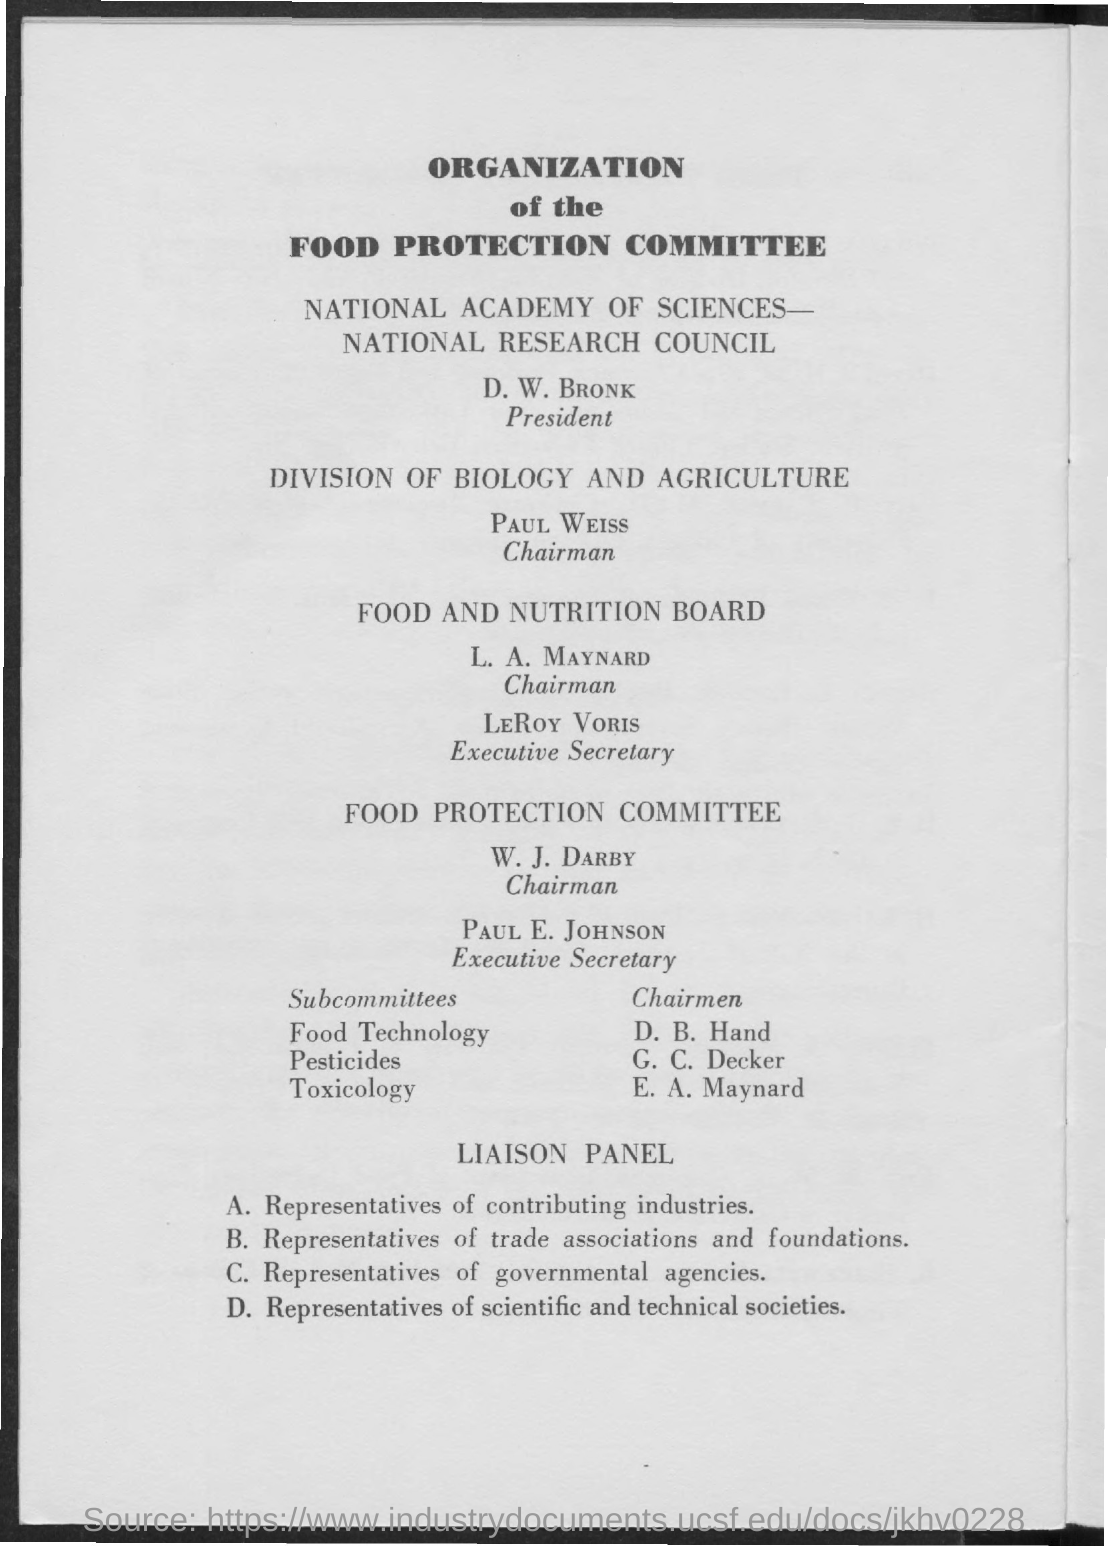Indicate a few pertinent items in this graphic. The Chairman of the Food and Nutrition Board is L. A. Maynard. The Food Protection Committee has an Executive Secretary named Paul E. Johnson. The executive secretary of the Food and Nutrition Board is Leroy Voris. 